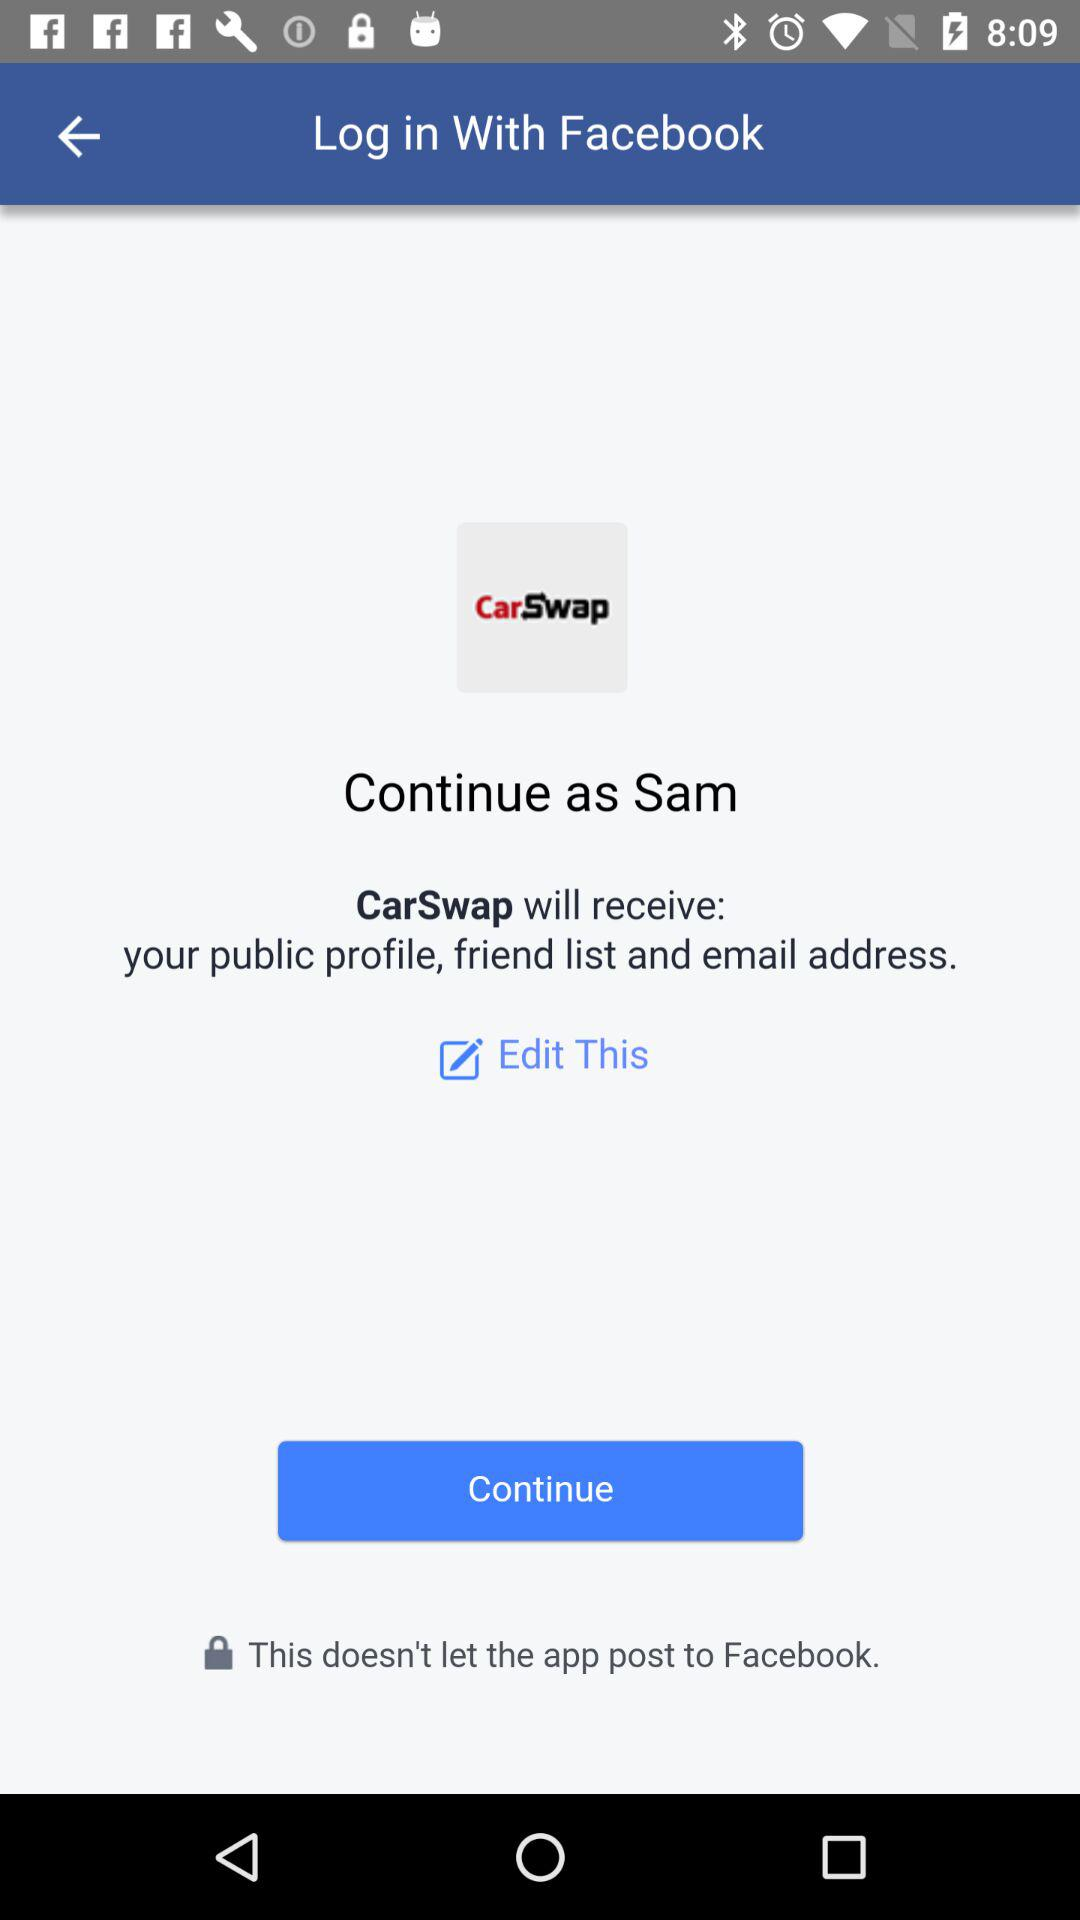What is the user name to continue on the login page? The user name to continue on the login page is Sam. 